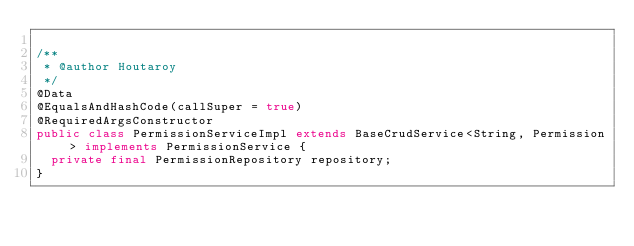Convert code to text. <code><loc_0><loc_0><loc_500><loc_500><_Java_>
/**
 * @author Houtaroy
 */
@Data
@EqualsAndHashCode(callSuper = true)
@RequiredArgsConstructor
public class PermissionServiceImpl extends BaseCrudService<String, Permission> implements PermissionService {
  private final PermissionRepository repository;
}
</code> 